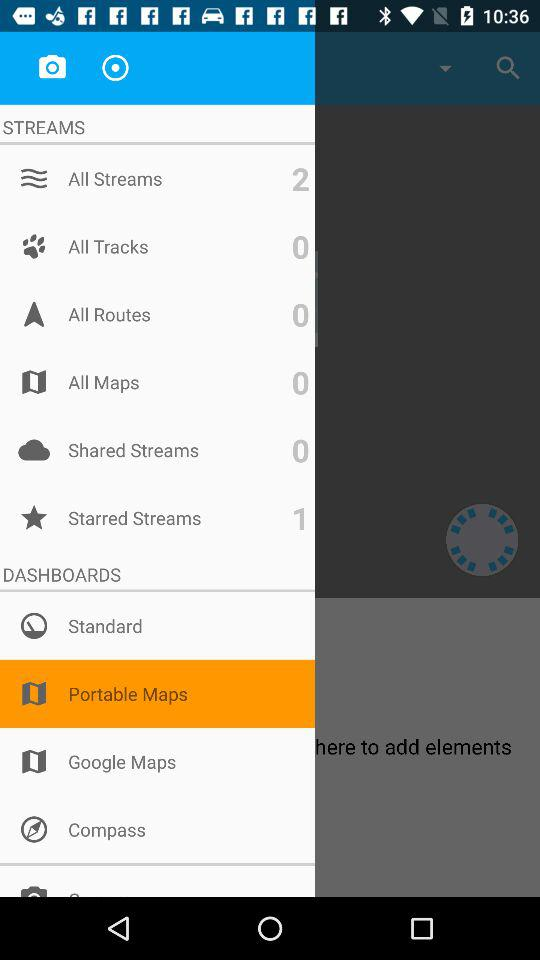Which item has been selected? The item that has been selected is "Portable Maps". 